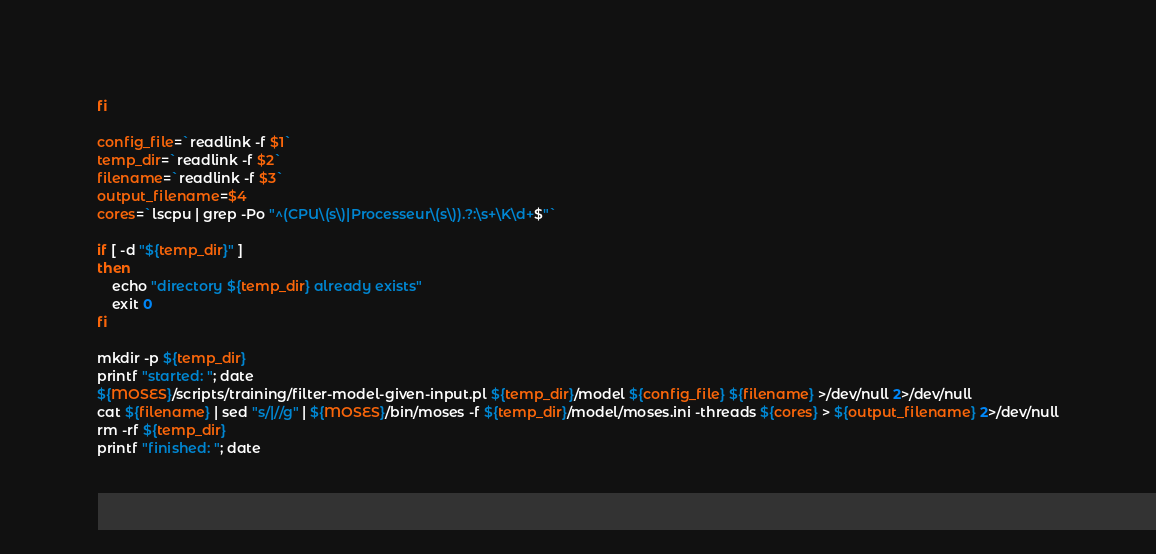Convert code to text. <code><loc_0><loc_0><loc_500><loc_500><_Bash_>fi

config_file=`readlink -f $1`
temp_dir=`readlink -f $2`
filename=`readlink -f $3`
output_filename=$4
cores=`lscpu | grep -Po "^(CPU\(s\)|Processeur\(s\)).?:\s+\K\d+$"`

if [ -d "${temp_dir}" ]
then
    echo "directory ${temp_dir} already exists"
    exit 0
fi

mkdir -p ${temp_dir}
printf "started: "; date
${MOSES}/scripts/training/filter-model-given-input.pl ${temp_dir}/model ${config_file} ${filename} >/dev/null 2>/dev/null
cat ${filename} | sed "s/|//g" | ${MOSES}/bin/moses -f ${temp_dir}/model/moses.ini -threads ${cores} > ${output_filename} 2>/dev/null
rm -rf ${temp_dir}
printf "finished: "; date

</code> 